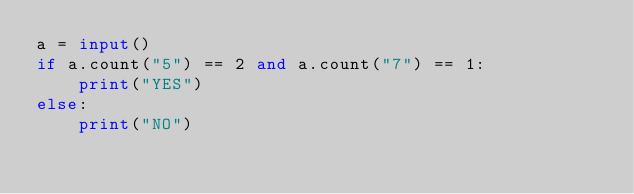<code> <loc_0><loc_0><loc_500><loc_500><_Python_>a = input()
if a.count("5") == 2 and a.count("7") == 1:
    print("YES")
else:
    print("NO")
</code> 